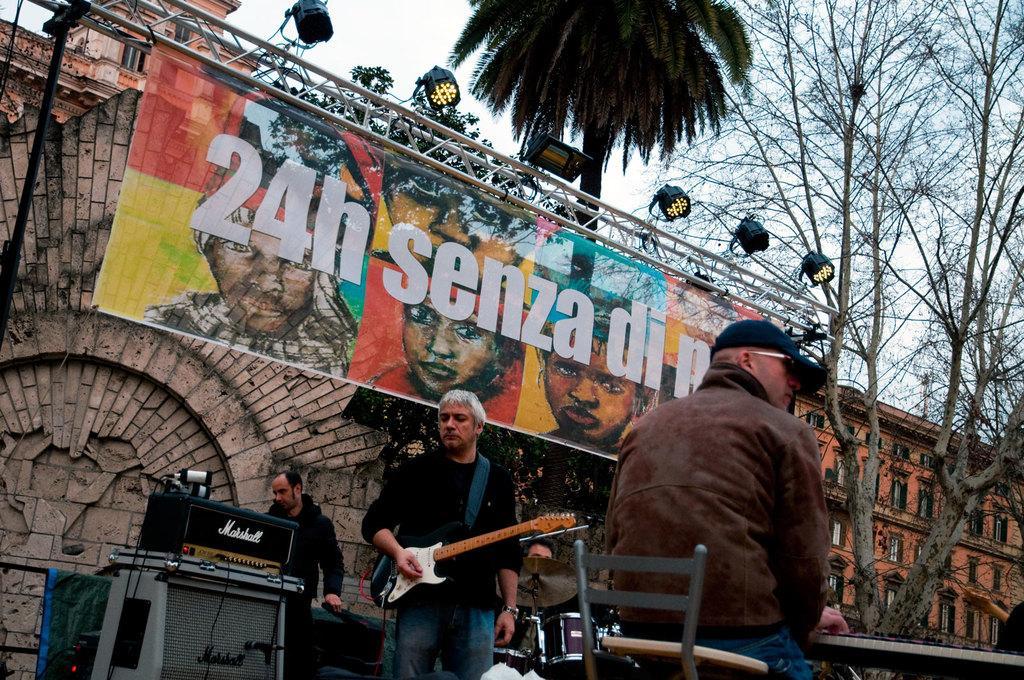How would you summarize this image in a sentence or two? As we can see in the image, there are three persons. The person on the right is sitting on chair and he is wearing blue color hat. The person in the middle is holding guitar in his hand and the person on the left is standing and there is a building over here. On building there is a big banner and lights and there are trees. On the top there is a sky. 